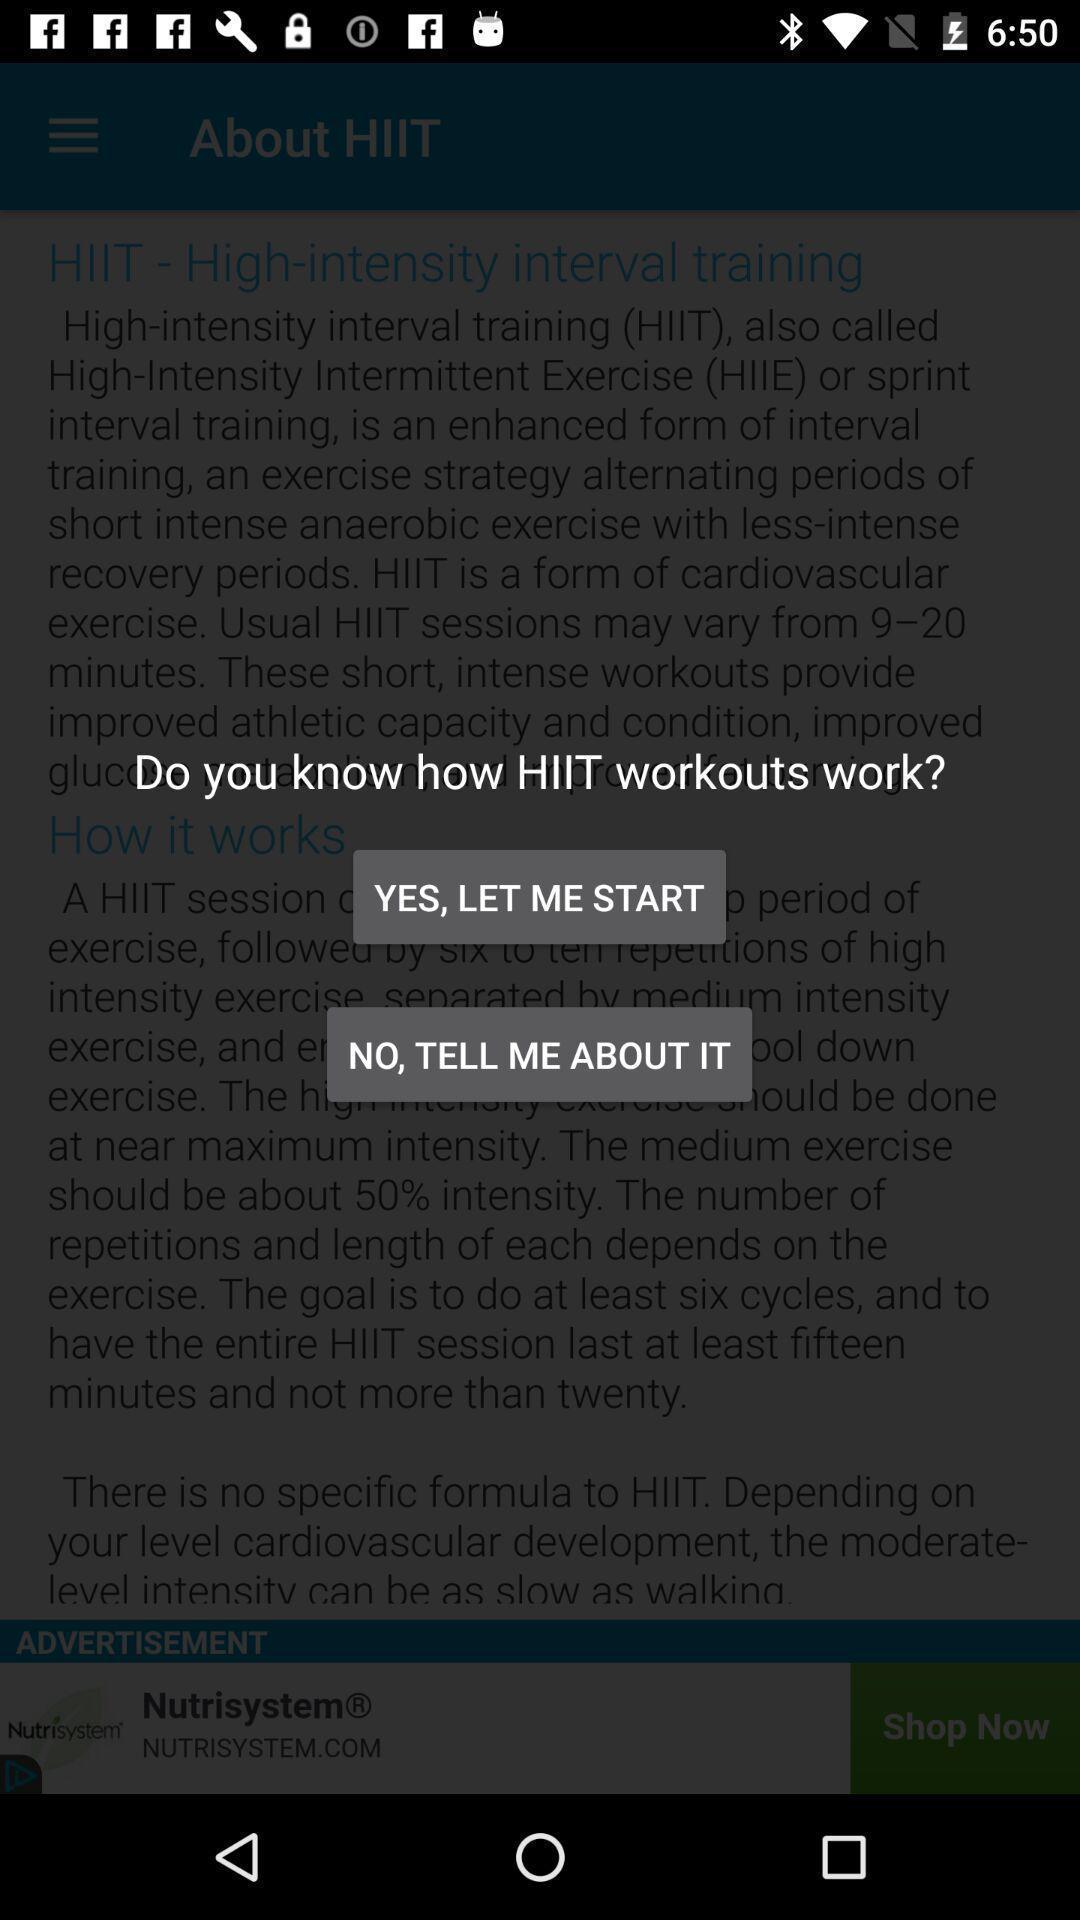Summarize the main components in this picture. Pop-up asking question in a fitness application. 